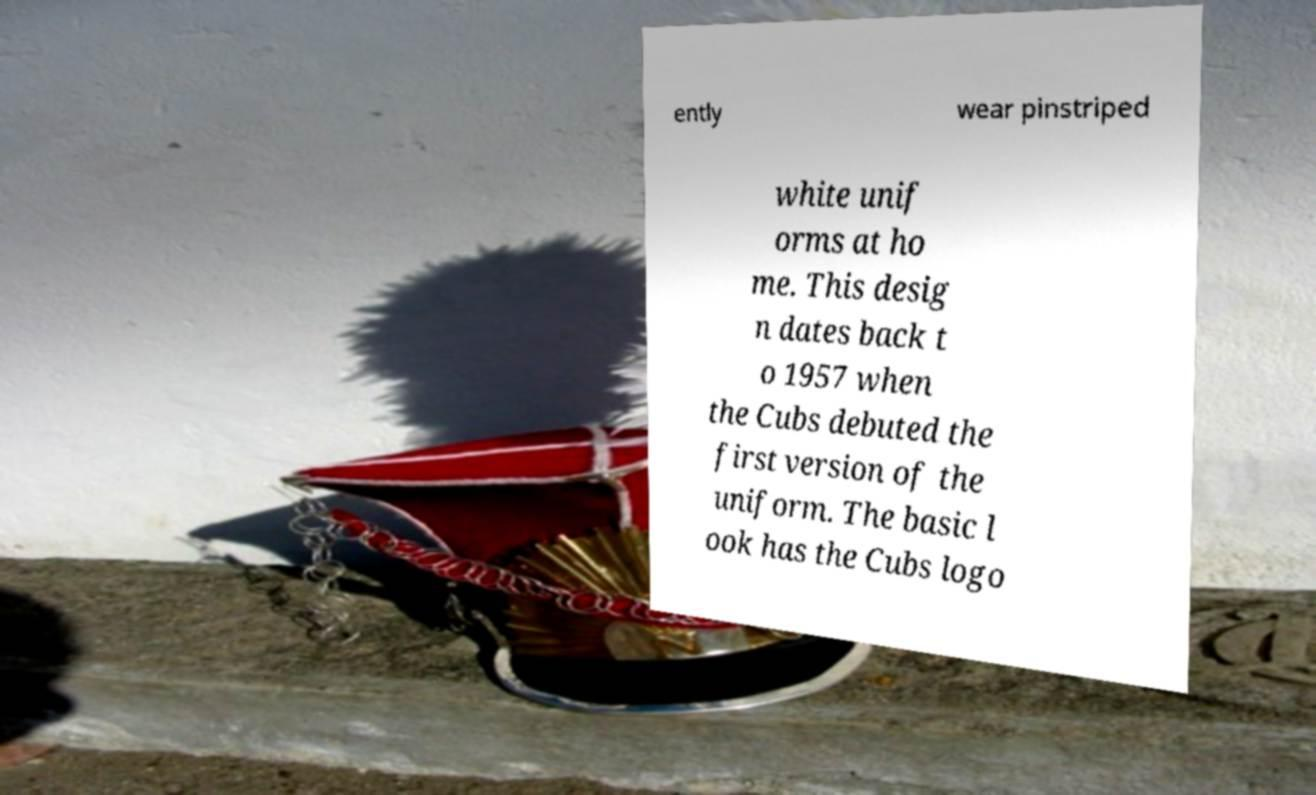Could you assist in decoding the text presented in this image and type it out clearly? ently wear pinstriped white unif orms at ho me. This desig n dates back t o 1957 when the Cubs debuted the first version of the uniform. The basic l ook has the Cubs logo 